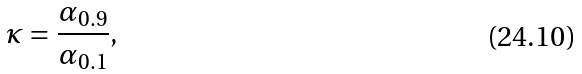Convert formula to latex. <formula><loc_0><loc_0><loc_500><loc_500>\kappa = \frac { \alpha _ { 0 . 9 } } { \alpha _ { 0 . 1 } } ,</formula> 